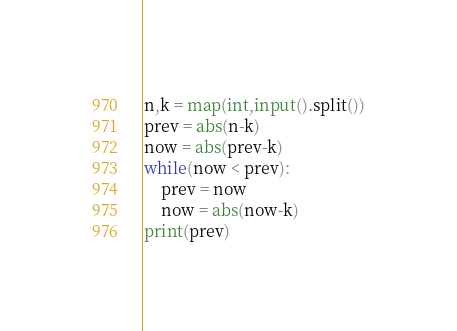<code> <loc_0><loc_0><loc_500><loc_500><_Python_>n,k = map(int,input().split())
prev = abs(n-k)
now = abs(prev-k)
while(now < prev):
    prev = now
    now = abs(now-k)
print(prev)</code> 